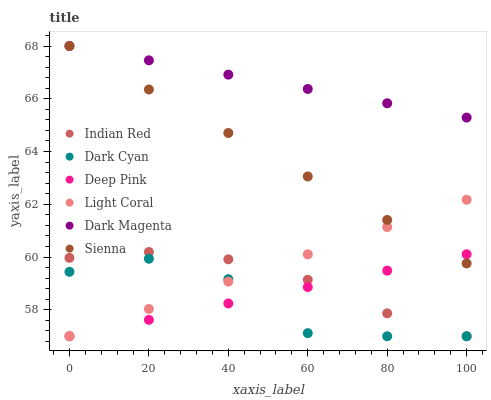Does Dark Cyan have the minimum area under the curve?
Answer yes or no. Yes. Does Dark Magenta have the maximum area under the curve?
Answer yes or no. Yes. Does Deep Pink have the minimum area under the curve?
Answer yes or no. No. Does Deep Pink have the maximum area under the curve?
Answer yes or no. No. Is Light Coral the smoothest?
Answer yes or no. Yes. Is Dark Cyan the roughest?
Answer yes or no. Yes. Is Deep Pink the smoothest?
Answer yes or no. No. Is Deep Pink the roughest?
Answer yes or no. No. Does Deep Pink have the lowest value?
Answer yes or no. Yes. Does Dark Magenta have the lowest value?
Answer yes or no. No. Does Dark Magenta have the highest value?
Answer yes or no. Yes. Does Deep Pink have the highest value?
Answer yes or no. No. Is Dark Cyan less than Dark Magenta?
Answer yes or no. Yes. Is Dark Magenta greater than Indian Red?
Answer yes or no. Yes. Does Deep Pink intersect Indian Red?
Answer yes or no. Yes. Is Deep Pink less than Indian Red?
Answer yes or no. No. Is Deep Pink greater than Indian Red?
Answer yes or no. No. Does Dark Cyan intersect Dark Magenta?
Answer yes or no. No. 